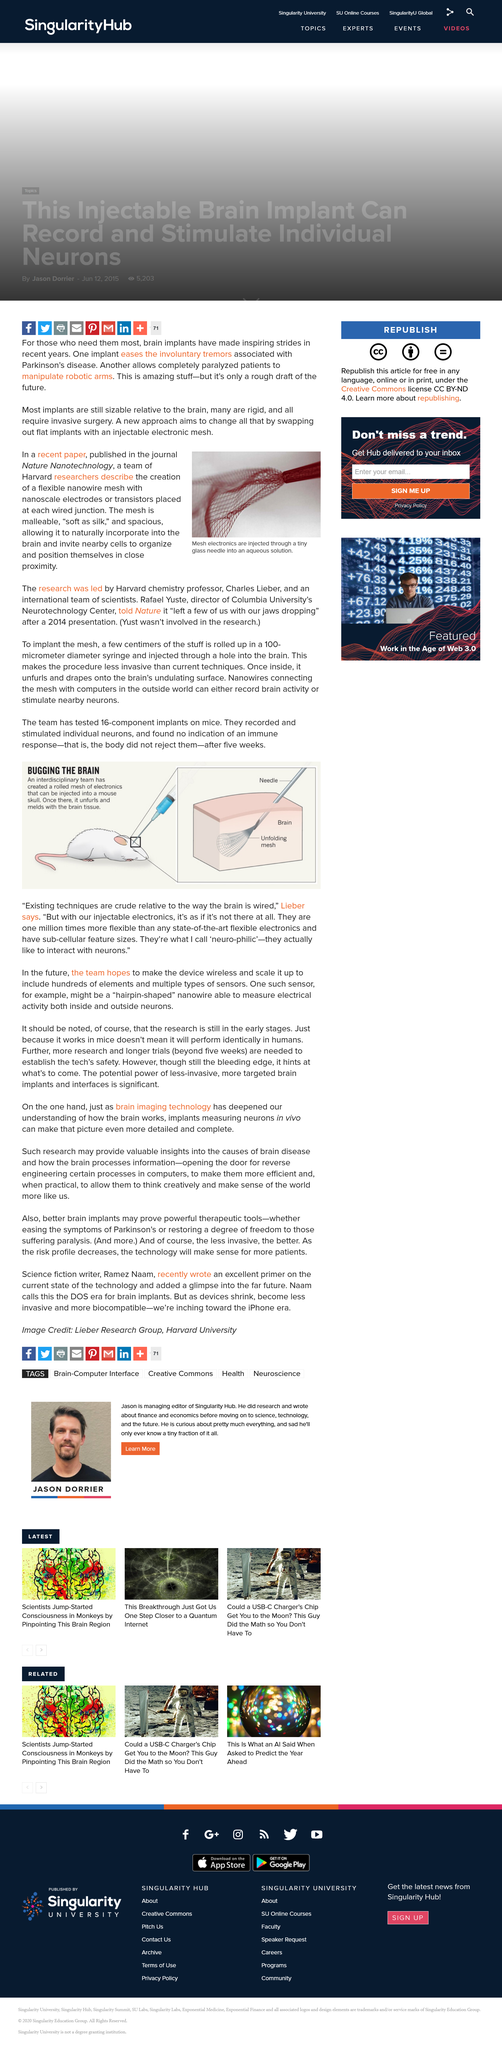Specify some key components in this picture. The caption of the photo states that the mesh electronics are being injected through a tiny glass needle into an aqueous solution. Our team hopes to achieve two important goals in the future. First, we aim to make the device wireless, which will allow for more flexibility and convenience in its use. Second, we plan to scale up the device to include hundreds of elements, in order to increase its capabilities and effectiveness. These two goals will help us to further improve the device and make it more useful for our target audience. It is necessary for trials to exceed 5 weeks in duration in order to establish the safety of the technology. Yes, most implants are still sizable in relation to the brain. Lieber was a member of an interdisciplinary team, and this team was the kind of team he was working in. 